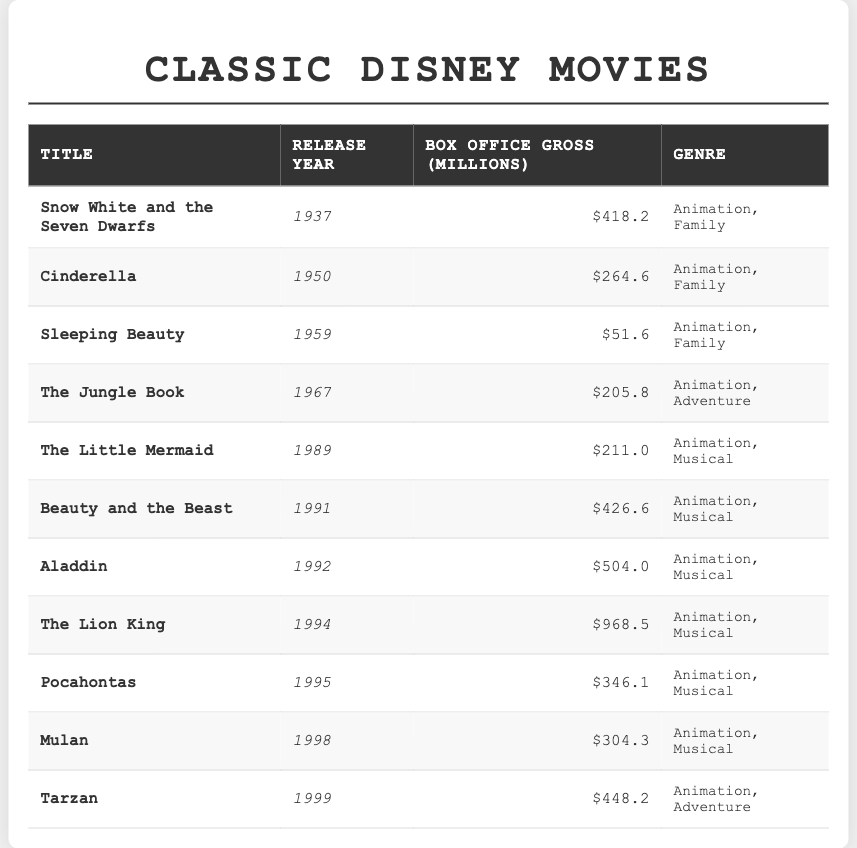What is the highest box office gross among the listed movies? The box office gross values from the table are: $418.2 million (Snow White and the Seven Dwarfs), $264.6 million (Cinderella), $51.6 million (Sleeping Beauty), $205.8 million (The Jungle Book), $211 million (The Little Mermaid), $426.6 million (Beauty and the Beast), $504 million (Aladdin), $968.5 million (The Lion King), $346.1 million (Pocahontas), $304.3 million (Mulan), and $448.2 million (Tarzan). The maximum value here is $968.5 million.
Answer: $968.5 million Which movie was released in 1995? Looking at the release years in the table, the movie listed for the year 1995 is Pocahontas.
Answer: Pocahontas How much more did The Lion King earn at the box office compared to Sleeping Beauty? The Lion King's box office gross is $968.5 million and Sleeping Beauty's is $51.6 million. To find the difference, we subtract: $968.5 million - $51.6 million = $916.9 million.
Answer: $916.9 million What is the average box office gross of all the movies listed in the table? First, we need to sum all the box office gross amounts: $418.2 + $264.6 + $51.6 + $205.8 + $211.0 + $426.6 + $504.0 + $968.5 + $346.1 + $304.3 + $448.2 = $3,405.9 million. There are 11 movies, so the average is $3,405.9 million / 11 = $309.6 million.
Answer: $309.6 million Is Beauty and the Beast the only movie with a box office gross above $400 million? The box office gross values are being evaluated: Beauty and the Beast grossed $426.6 million and also we check other movies: Aladdin ($504 million), The Lion King ($968.5 million), and Tarzan ($448.2 million). Thus, Beauty and the Beast is not the only movie above $400 million.
Answer: No List the movies that are categorized as "Animation, Musical". The table shows the following movies in the "Animation, Musical" genre: The Little Mermaid, Beauty and the Beast, Aladdin, The Lion King, Pocahontas, Mulan.
Answer: The Little Mermaid, Beauty and the Beast, Aladdin, The Lion King, Pocahontas, Mulan What is the difference in box office gross between the highest and lowest grossing movies? The highest grossing movie is The Lion King at $968.5 million, and the lowest grossing is Sleeping Beauty at $51.6 million. To find the difference, we calculate $968.5 million - $51.6 million = $916.9 million.
Answer: $916.9 million How many movies were released between 1990 and 2000? In the table, the movies released between 1990 and 2000 are: The Little Mermaid (1989), Beauty and the Beast (1991), Aladdin (1992), The Lion King (1994), Pocahontas (1995), Mulan (1998), and Tarzan (1999). Counting these, we have 7 movies.
Answer: 7 